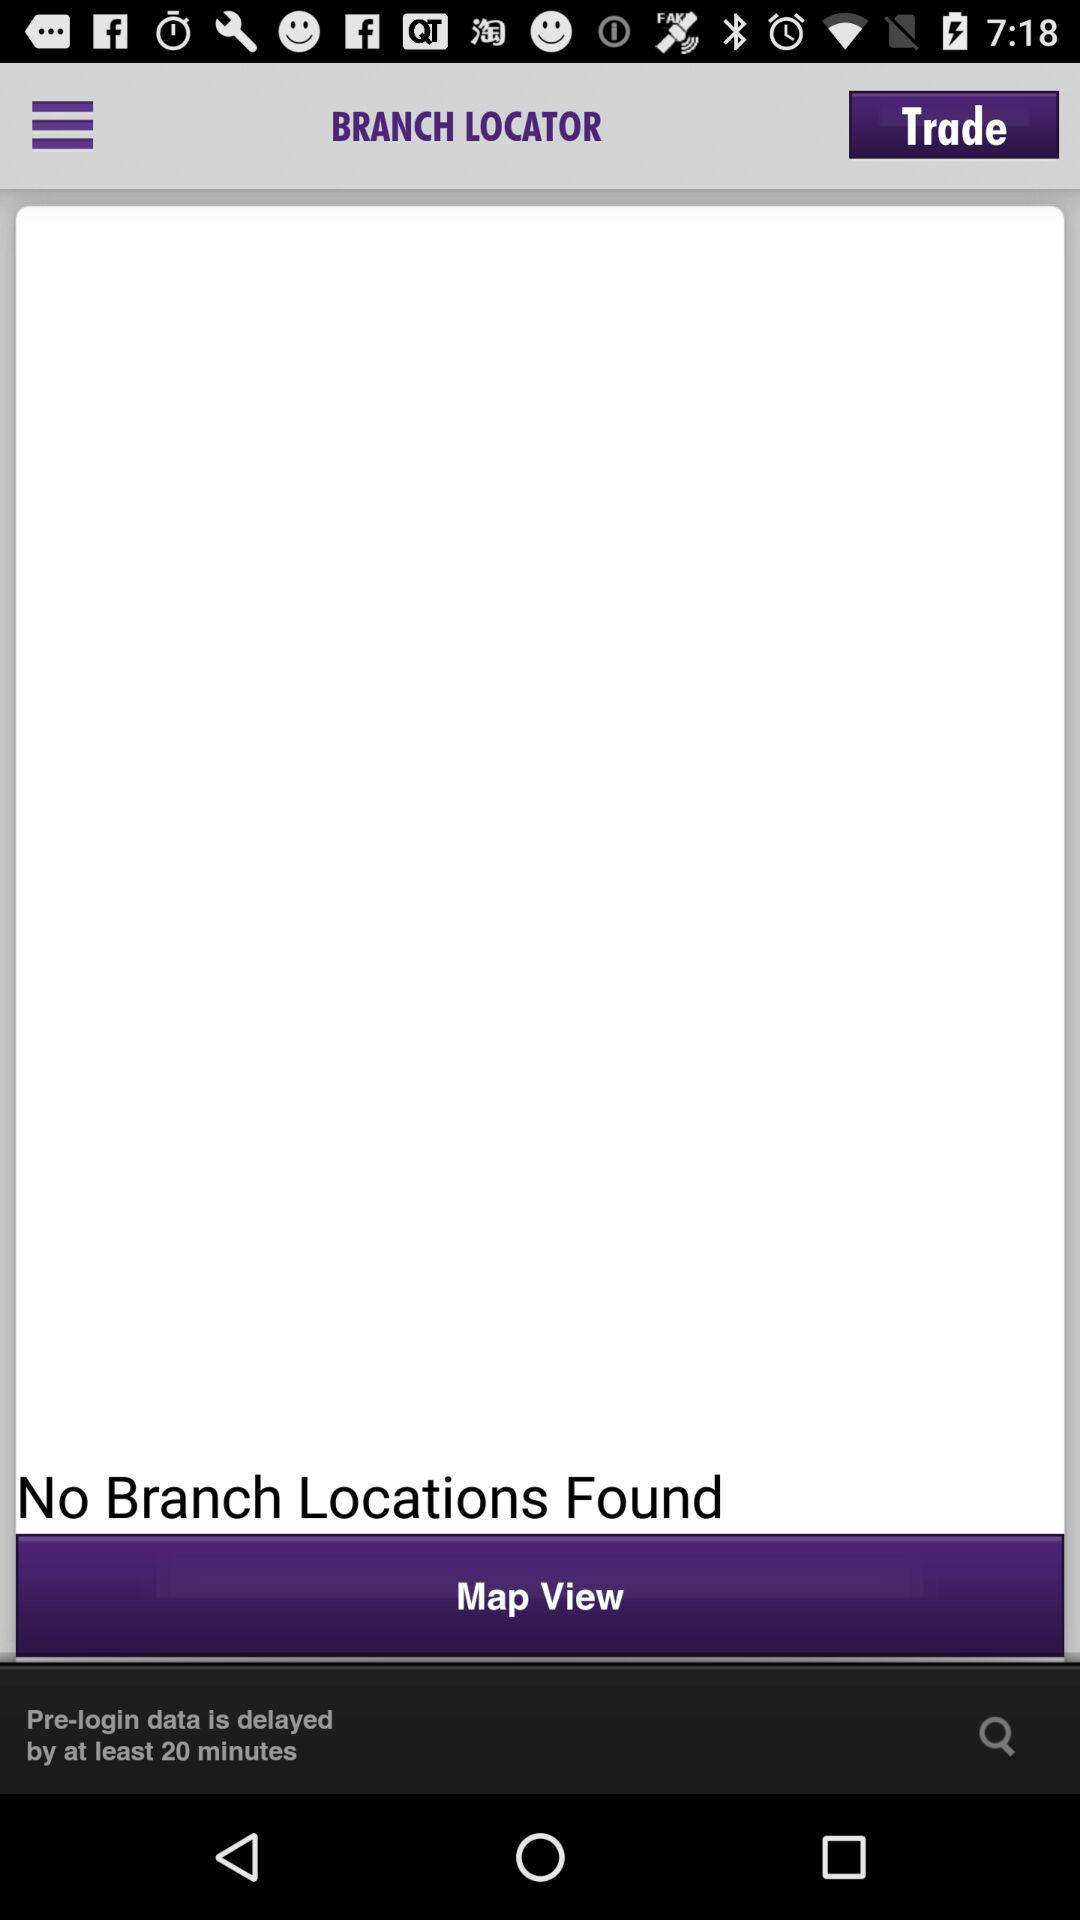What is the minimum delayed time for pre-login data? The minimum delayed time for pre-login data is at least 20 minutes. 